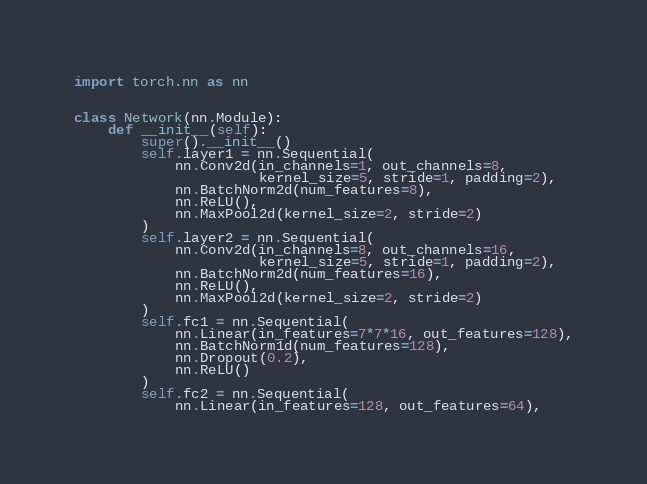Convert code to text. <code><loc_0><loc_0><loc_500><loc_500><_Python_>import torch.nn as nn


class Network(nn.Module):
    def __init__(self):
        super().__init__()
        self.layer1 = nn.Sequential(
            nn.Conv2d(in_channels=1, out_channels=8,
                      kernel_size=5, stride=1, padding=2),
            nn.BatchNorm2d(num_features=8),
            nn.ReLU(),
            nn.MaxPool2d(kernel_size=2, stride=2)
        )
        self.layer2 = nn.Sequential(
            nn.Conv2d(in_channels=8, out_channels=16,
                      kernel_size=5, stride=1, padding=2),
            nn.BatchNorm2d(num_features=16),
            nn.ReLU(),
            nn.MaxPool2d(kernel_size=2, stride=2)
        )
        self.fc1 = nn.Sequential(
            nn.Linear(in_features=7*7*16, out_features=128),
            nn.BatchNorm1d(num_features=128),
            nn.Dropout(0.2),
            nn.ReLU()
        )
        self.fc2 = nn.Sequential(
            nn.Linear(in_features=128, out_features=64),</code> 